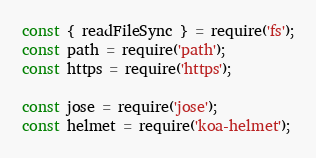Convert code to text. <code><loc_0><loc_0><loc_500><loc_500><_JavaScript_>const { readFileSync } = require('fs');
const path = require('path');
const https = require('https');

const jose = require('jose');
const helmet = require('koa-helmet');</code> 